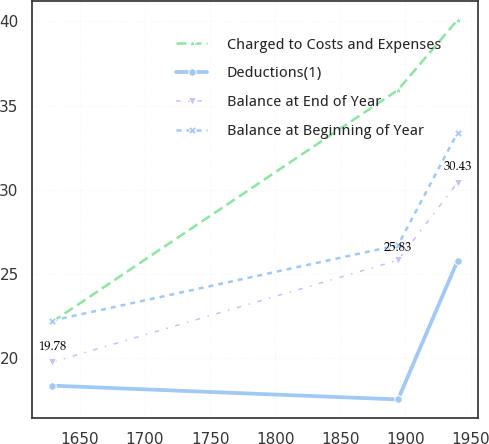<chart> <loc_0><loc_0><loc_500><loc_500><line_chart><ecel><fcel>Charged to Costs and Expenses<fcel>Deductions(1)<fcel>Balance at End of Year<fcel>Balance at Beginning of Year<nl><fcel>1628.75<fcel>22.17<fcel>18.39<fcel>19.78<fcel>22.25<nl><fcel>1894.25<fcel>35.93<fcel>17.57<fcel>25.83<fcel>26.72<nl><fcel>1939.93<fcel>40.08<fcel>25.79<fcel>30.43<fcel>33.39<nl></chart> 